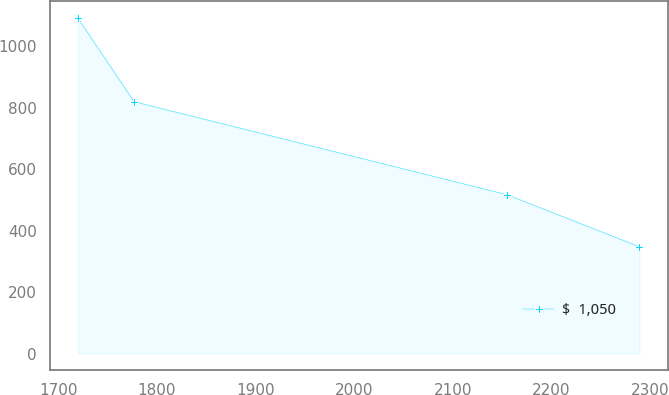<chart> <loc_0><loc_0><loc_500><loc_500><line_chart><ecel><fcel>$  1,050<nl><fcel>1719.97<fcel>1091.15<nl><fcel>1776.92<fcel>819.33<nl><fcel>2154.82<fcel>517.13<nl><fcel>2289.45<fcel>347.4<nl></chart> 